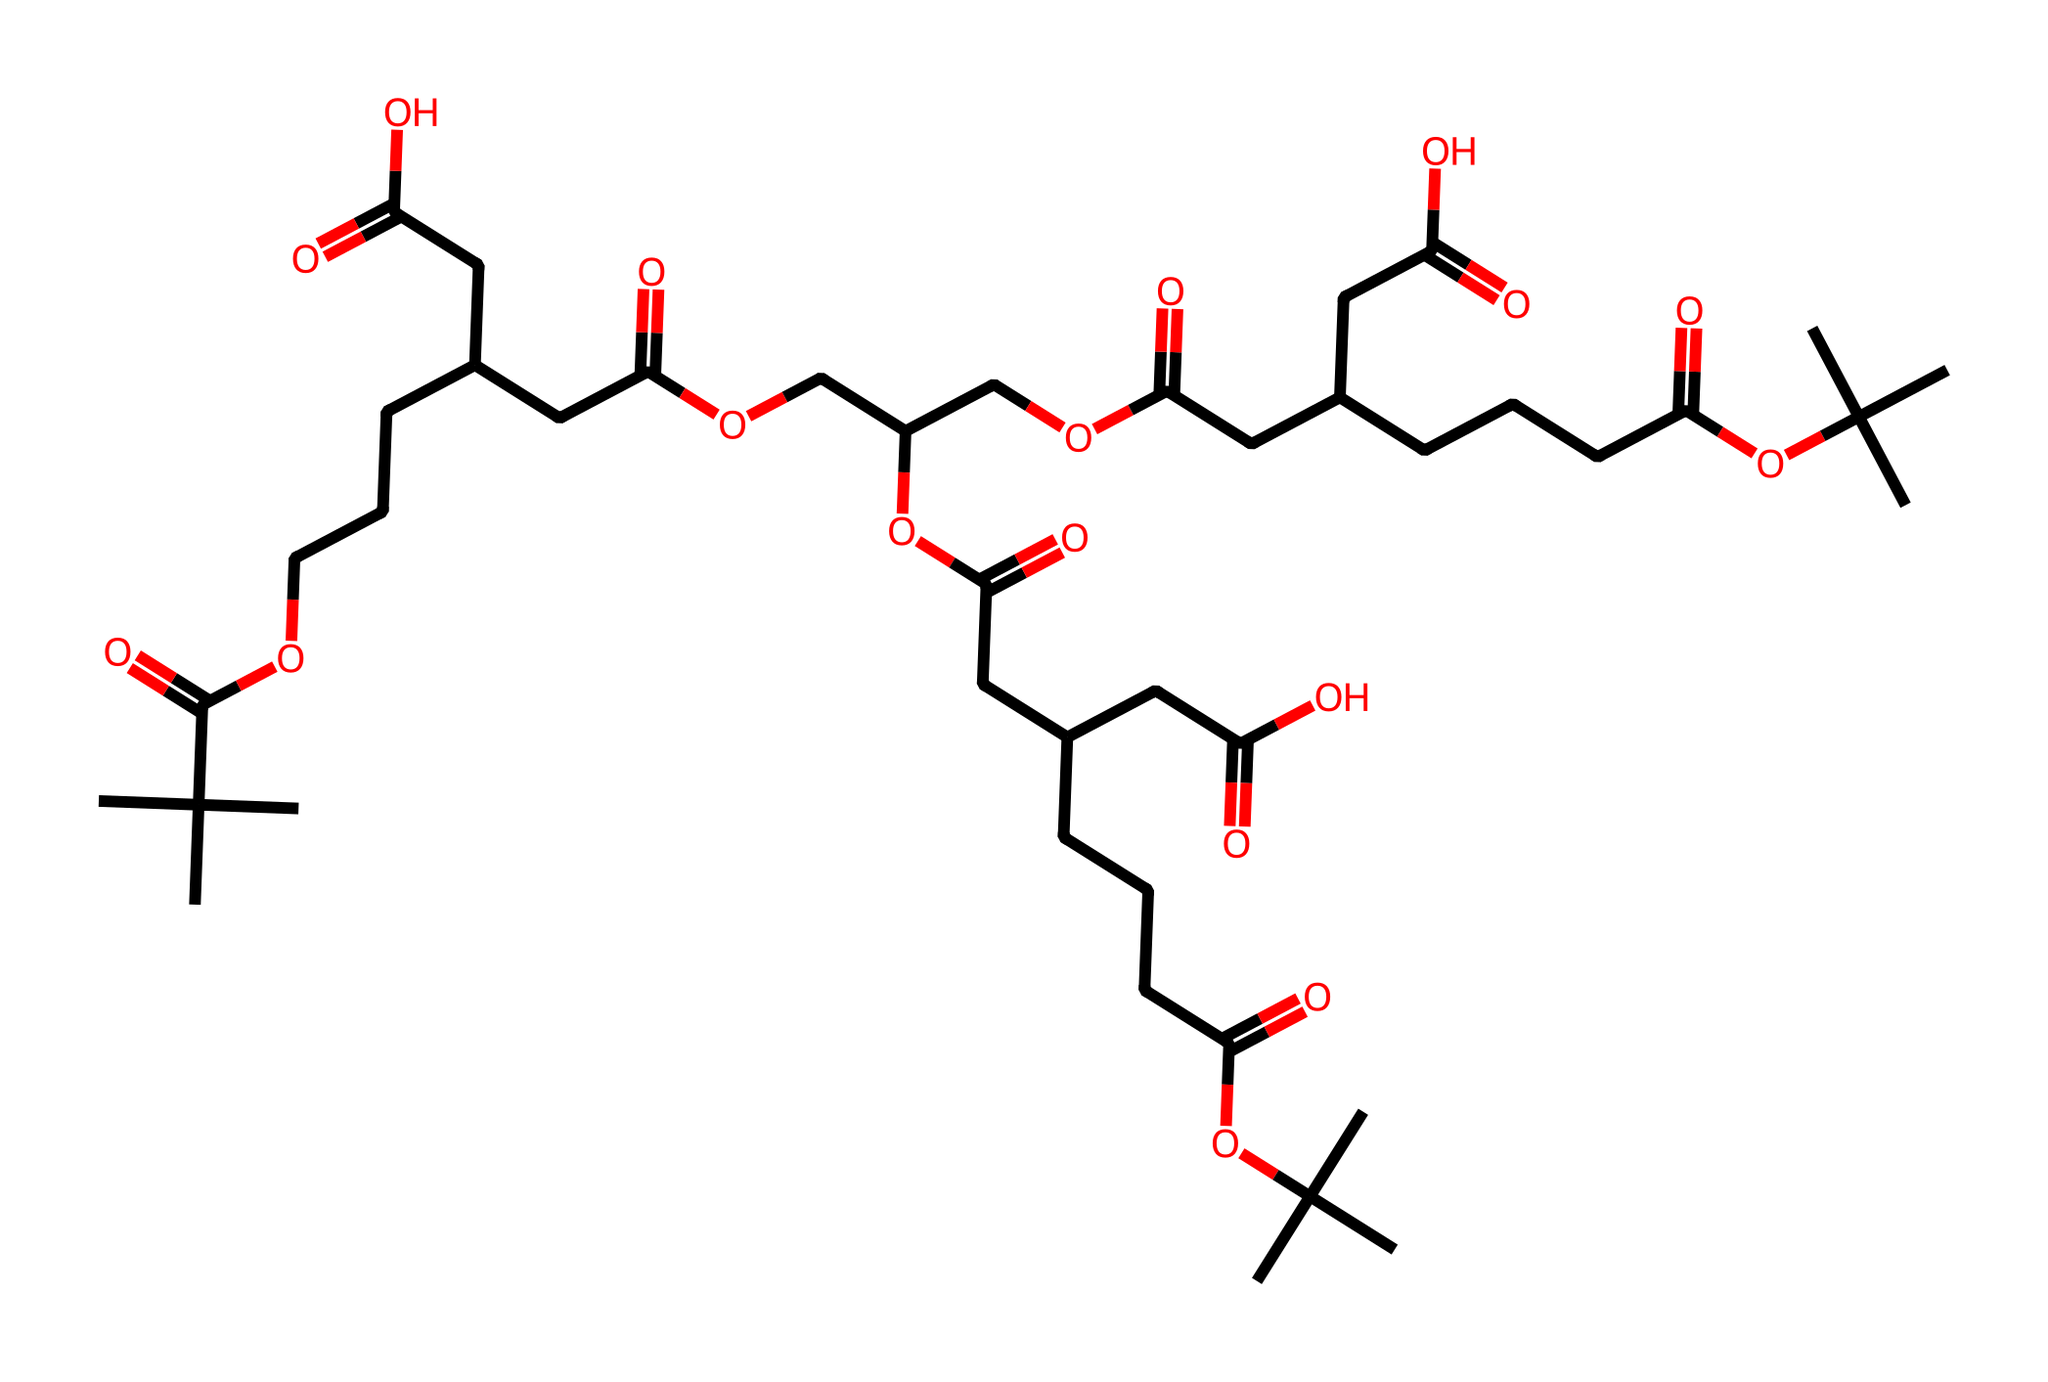What is the total number of carbon atoms in this molecule? To determine the total number of carbon atoms, we count the "C" in the SMILES representation, which indicates the presence of carbon atoms in the structure. In this SMILES, there are 28 occurrences of "C."
Answer: 28 How many ketone functional groups are present in this structure? The ketone functional group is characterized by the presence of a carbonyl group (C=O) between two carbon atoms. In the SMILES, we identify the "C(=O)" notation, which shows where these groups are located. There are a total of 5 instances of "C(=O)" in the structure, indicating 5 ketone functional groups.
Answer: 5 What is the longest chain of carbon atoms in this molecule? To find the longest chain, we visualize the linear arrangement of carbon atoms in the SMILES notation. By exploring the branches and counting the consecutive carbons, we find that the longest continuous carbon chain consists of 8 carbon atoms.
Answer: 8 Does this molecule have any functional acid groups? Functional acid groups in organic molecules are often represented by carboxylic acid groups (-COOH), which appear as "C(=O)O" in SMILES. As we parse the structure, we can find multiple instances of "C(=O)O," confirming the presence of functional acid groups.
Answer: Yes What type of reaction would this molecule most likely undergo to break down into simpler compounds? This molecule would likely undergo hydrolysis, a reaction with water that breaks ester or amide bonds, resulting in simpler organic acids and alcohols. The presence of multiple ester linkages suggests it could readily undergo this kind of reaction.
Answer: Hydrolysis 